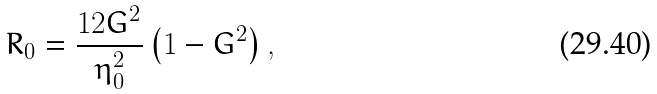Convert formula to latex. <formula><loc_0><loc_0><loc_500><loc_500>R _ { 0 } = \frac { 1 2 G ^ { 2 } } { \eta _ { 0 } ^ { 2 } } \left ( 1 - G ^ { 2 } \right ) ,</formula> 